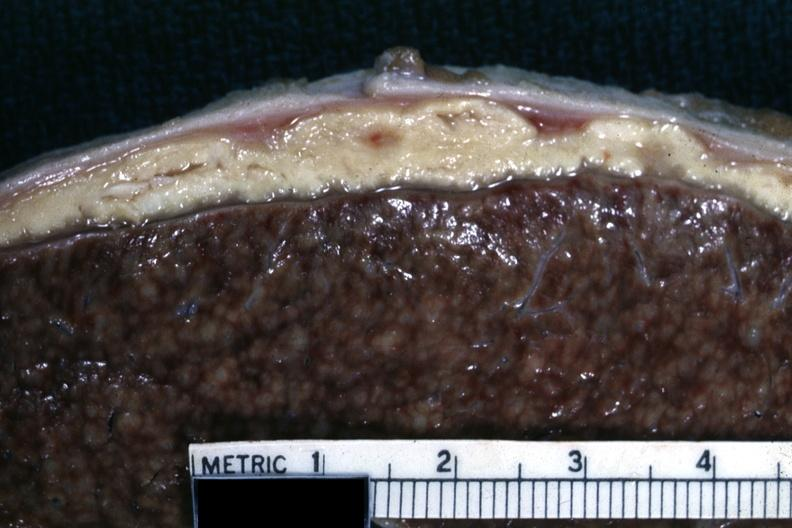what is this very typical?
Answer the question using a single word or phrase. Cold abscess material 